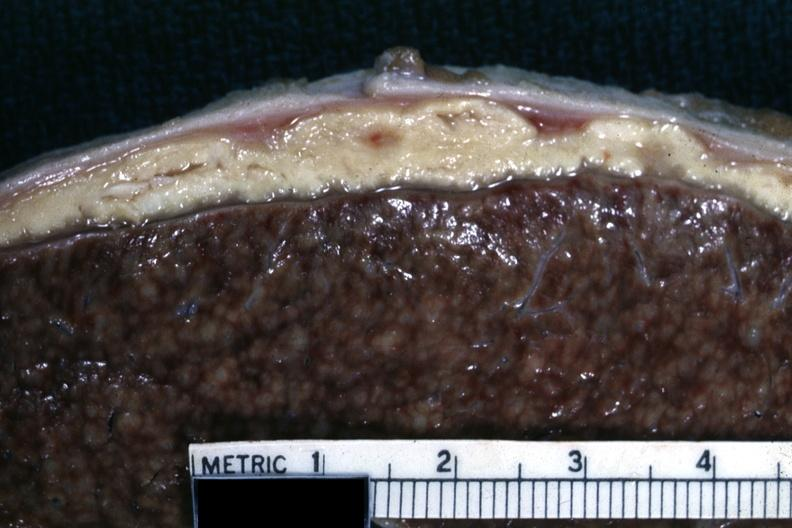what is this very typical?
Answer the question using a single word or phrase. Cold abscess material 